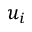<formula> <loc_0><loc_0><loc_500><loc_500>u _ { i }</formula> 